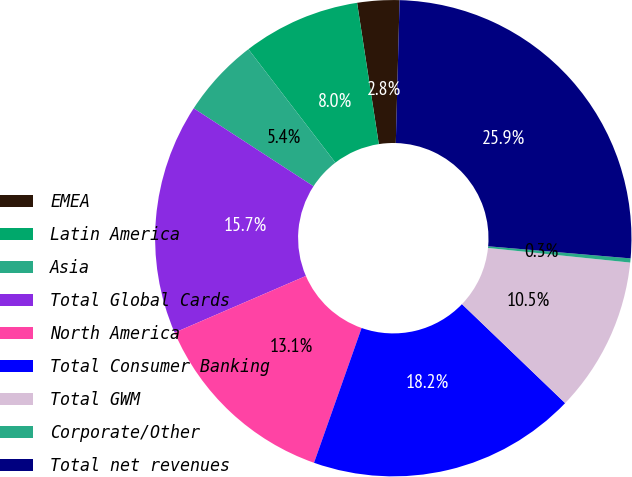<chart> <loc_0><loc_0><loc_500><loc_500><pie_chart><fcel>EMEA<fcel>Latin America<fcel>Asia<fcel>Total Global Cards<fcel>North America<fcel>Total Consumer Banking<fcel>Total GWM<fcel>Corporate/Other<fcel>Total net revenues<nl><fcel>2.85%<fcel>7.98%<fcel>5.41%<fcel>15.67%<fcel>13.11%<fcel>18.23%<fcel>10.54%<fcel>0.28%<fcel>25.93%<nl></chart> 